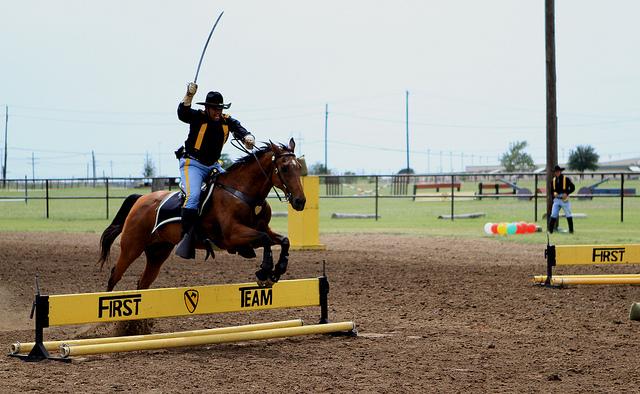What animal is shown?
Be succinct. Horse. What color is the writing on the wood?
Write a very short answer. Black. What is the second word on the yellow wood?
Short answer required. Team. 